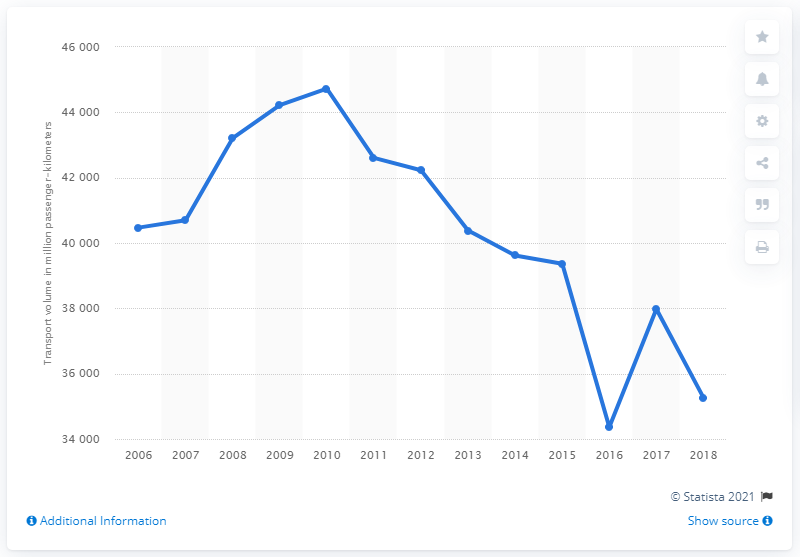Point out several critical features in this image. In 2018, the volume of passenger traffic reached 352,670 passenger-kilometers. 